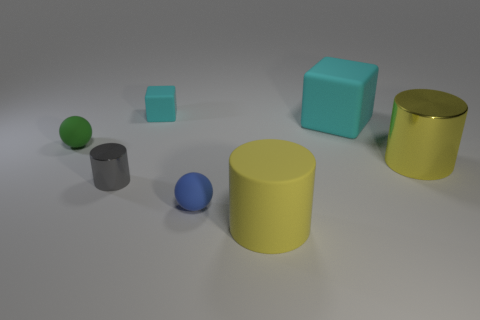There is a rubber sphere that is behind the large metal thing; is it the same size as the blue matte sphere in front of the gray metal cylinder?
Your answer should be compact. Yes. What is the shape of the large matte thing that is in front of the metal cylinder that is to the left of the large yellow matte cylinder?
Offer a very short reply. Cylinder. How many cylinders are to the right of the rubber cylinder?
Your answer should be compact. 1. There is a cylinder that is made of the same material as the small cyan block; what is its color?
Your answer should be compact. Yellow. There is a gray metal cylinder; does it have the same size as the metallic cylinder that is on the right side of the large rubber cylinder?
Your response must be concise. No. What size is the cyan matte block that is on the right side of the tiny rubber object in front of the matte sphere that is behind the big yellow metal thing?
Your answer should be compact. Large. How many matte things are large yellow things or small cubes?
Provide a succinct answer. 2. What is the color of the tiny rubber sphere that is on the left side of the tiny cylinder?
Your answer should be compact. Green. What is the shape of the cyan matte object that is the same size as the yellow shiny object?
Provide a short and direct response. Cube. There is a big matte cylinder; is its color the same as the shiny cylinder right of the small blue rubber ball?
Keep it short and to the point. Yes. 